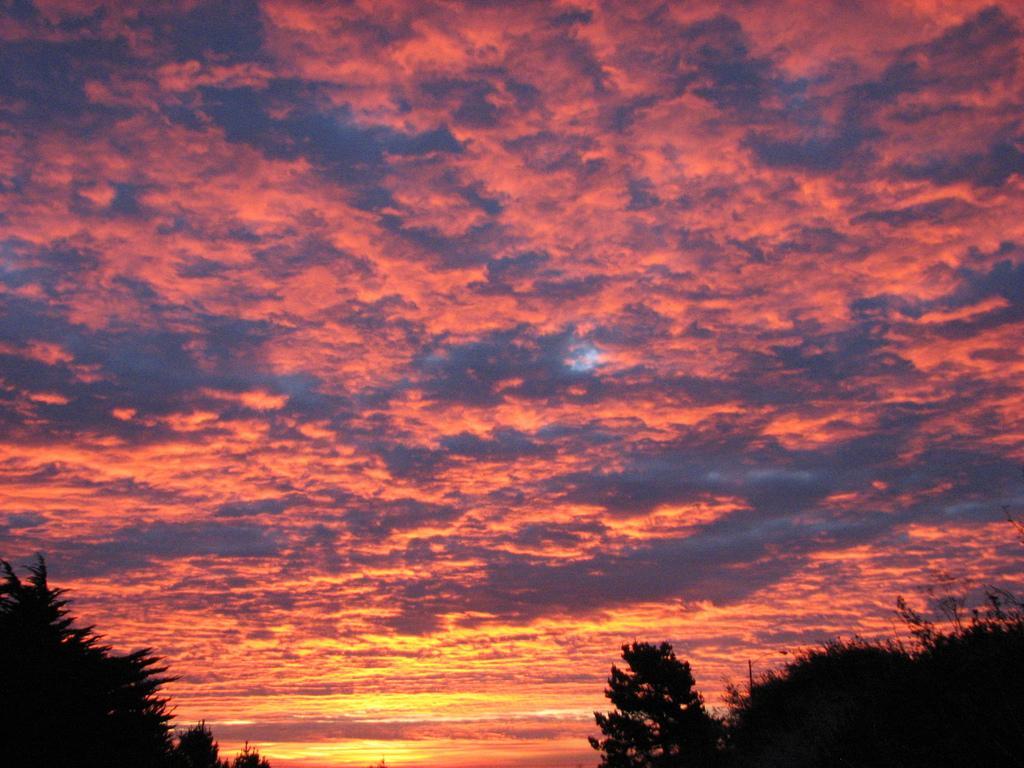Can you describe this image briefly? In this image we can see sky with clouds and trees. 